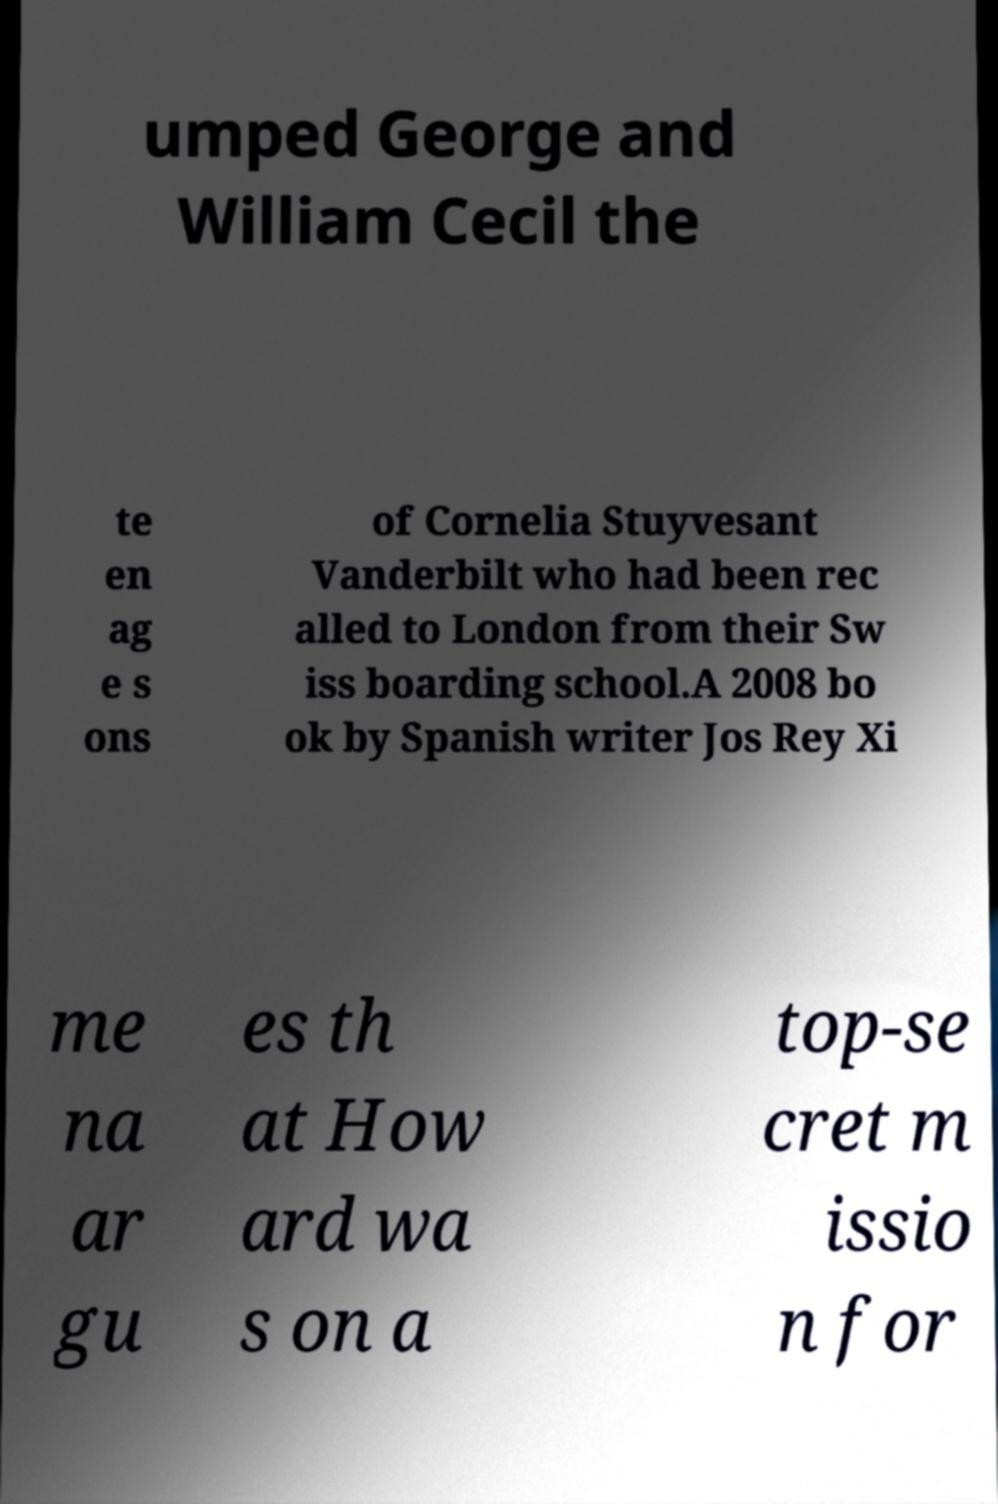Please read and relay the text visible in this image. What does it say? umped George and William Cecil the te en ag e s ons of Cornelia Stuyvesant Vanderbilt who had been rec alled to London from their Sw iss boarding school.A 2008 bo ok by Spanish writer Jos Rey Xi me na ar gu es th at How ard wa s on a top-se cret m issio n for 